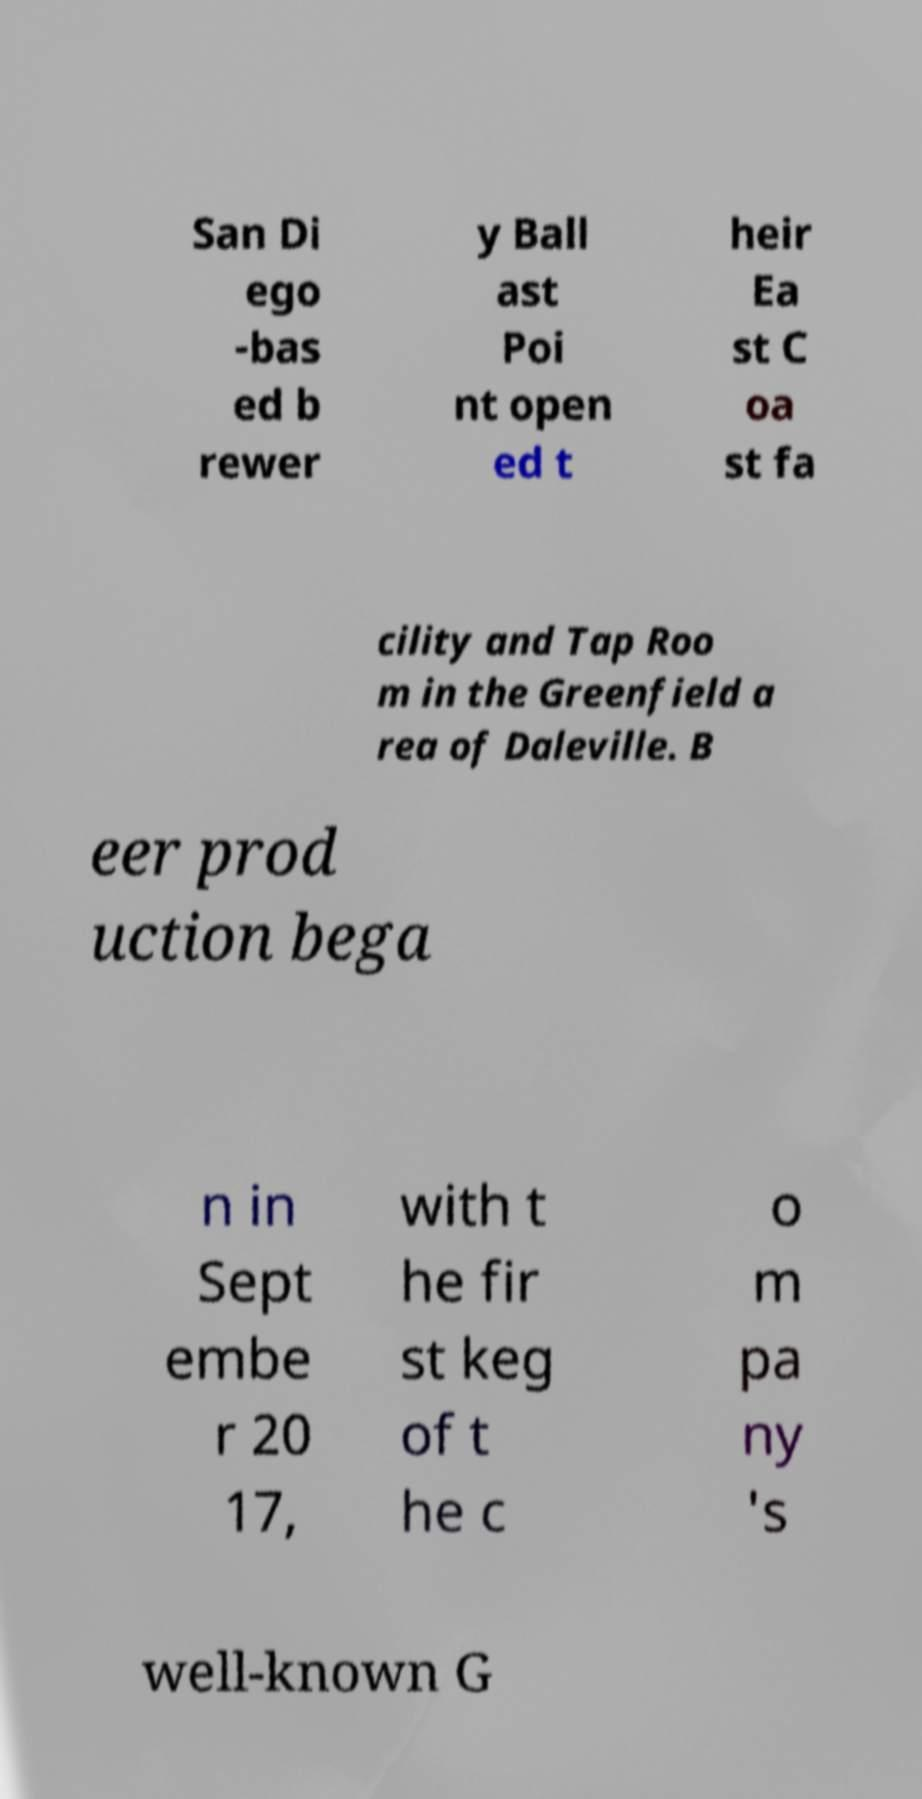Please identify and transcribe the text found in this image. San Di ego -bas ed b rewer y Ball ast Poi nt open ed t heir Ea st C oa st fa cility and Tap Roo m in the Greenfield a rea of Daleville. B eer prod uction bega n in Sept embe r 20 17, with t he fir st keg of t he c o m pa ny 's well-known G 